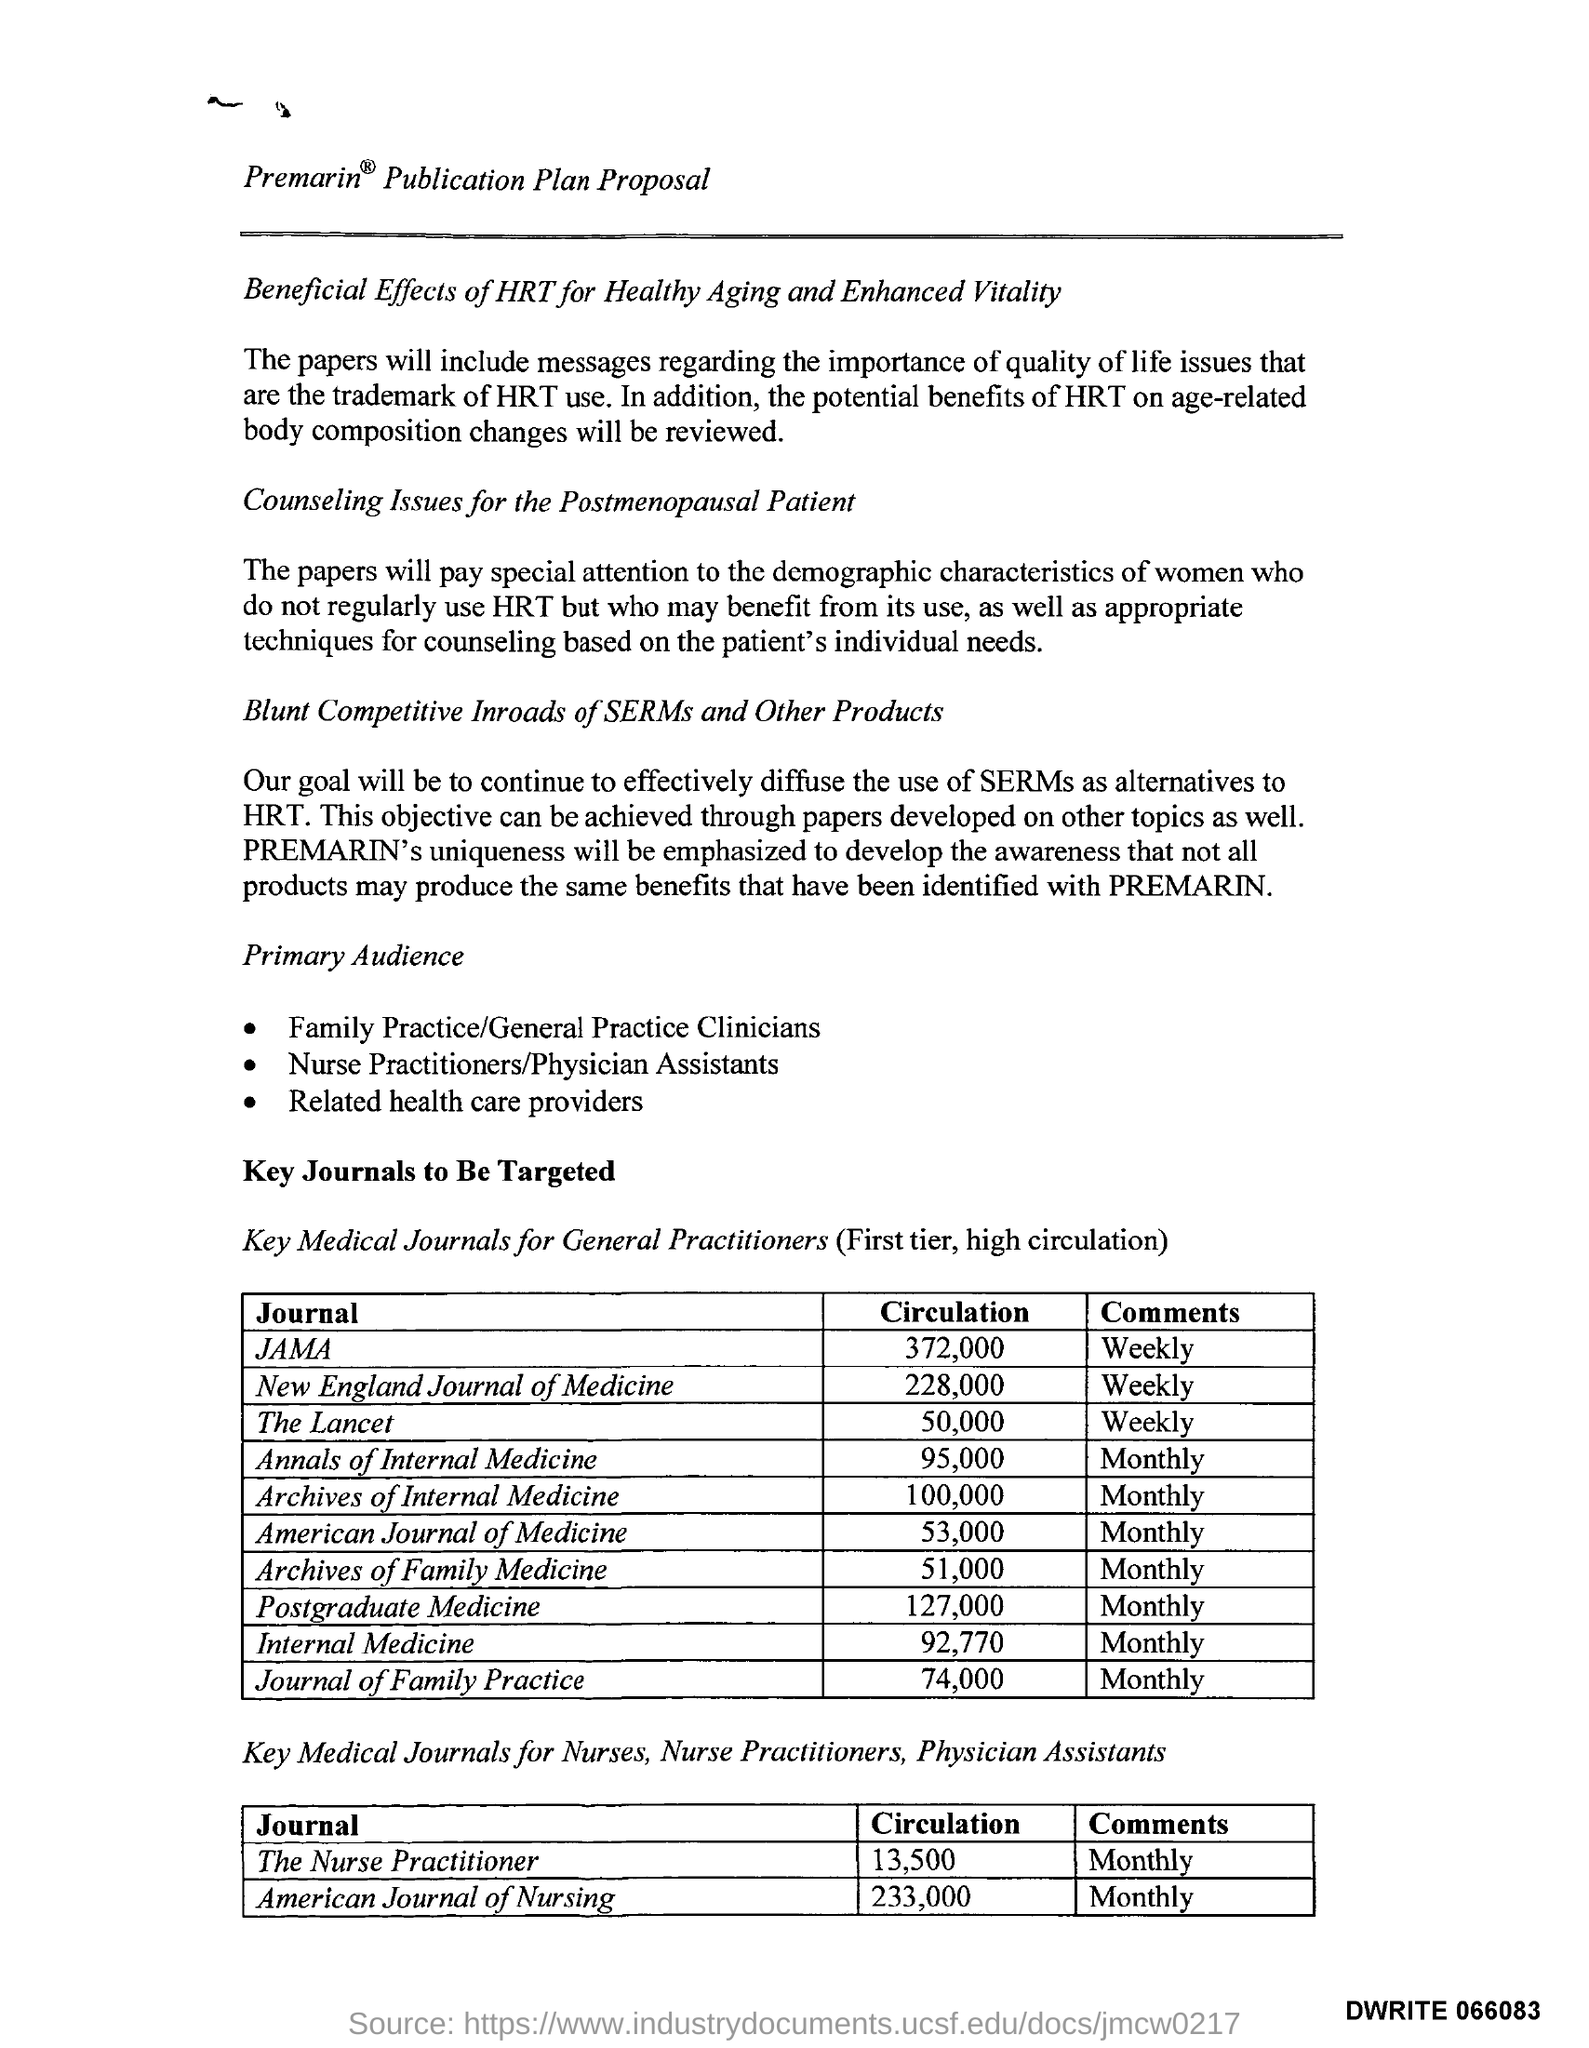Mention a couple of crucial points in this snapshot. JAMA, a journal for general practitioners, has the highest circulation among similar publications. 